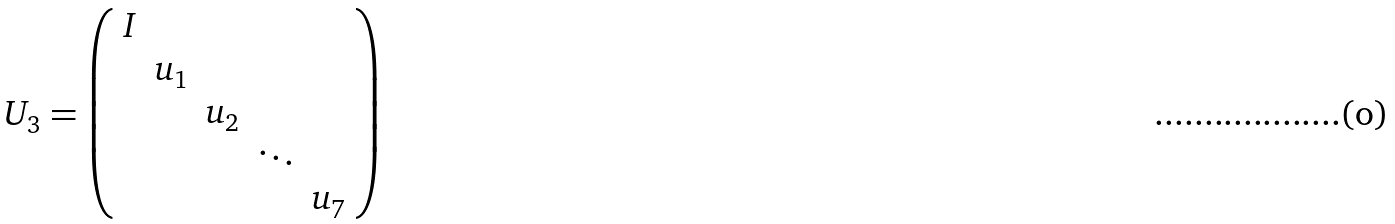<formula> <loc_0><loc_0><loc_500><loc_500>U _ { 3 } = \left ( \begin{array} { c c c c c } I & & & & \\ & u _ { 1 } & & & \\ & & u _ { 2 } & & \\ & & & \ddots & \\ & & & & u _ { 7 } \\ \end{array} \right )</formula> 